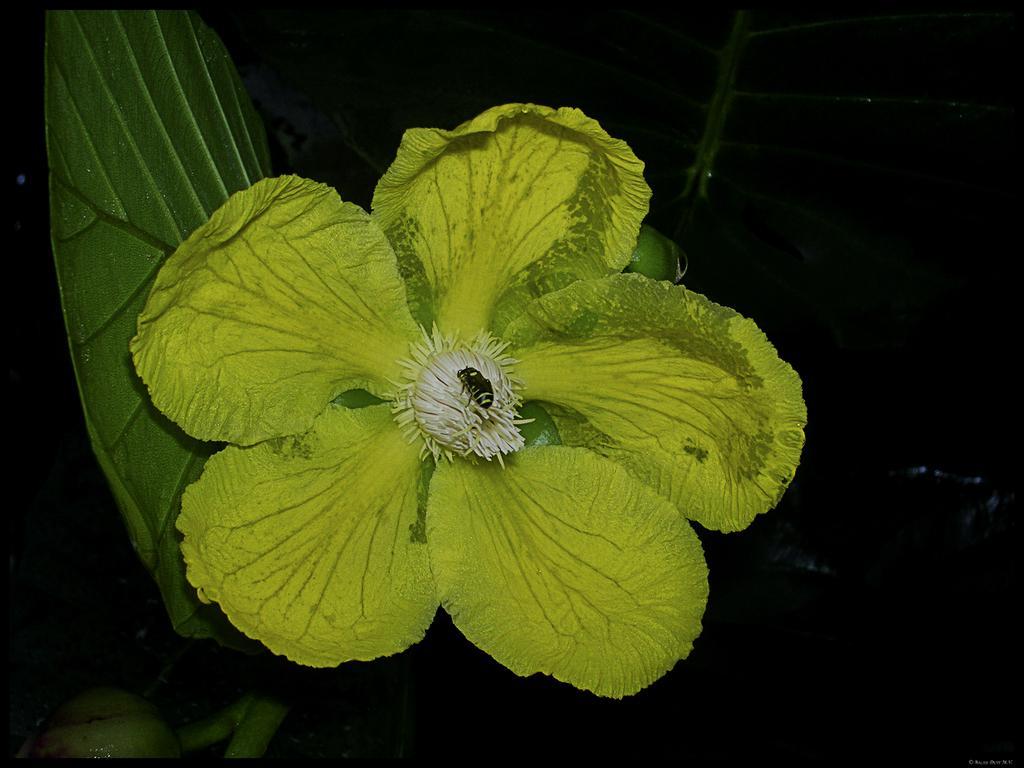How would you summarize this image in a sentence or two? This is zoom-in picture of a green color flower, behind one leaf is there. 